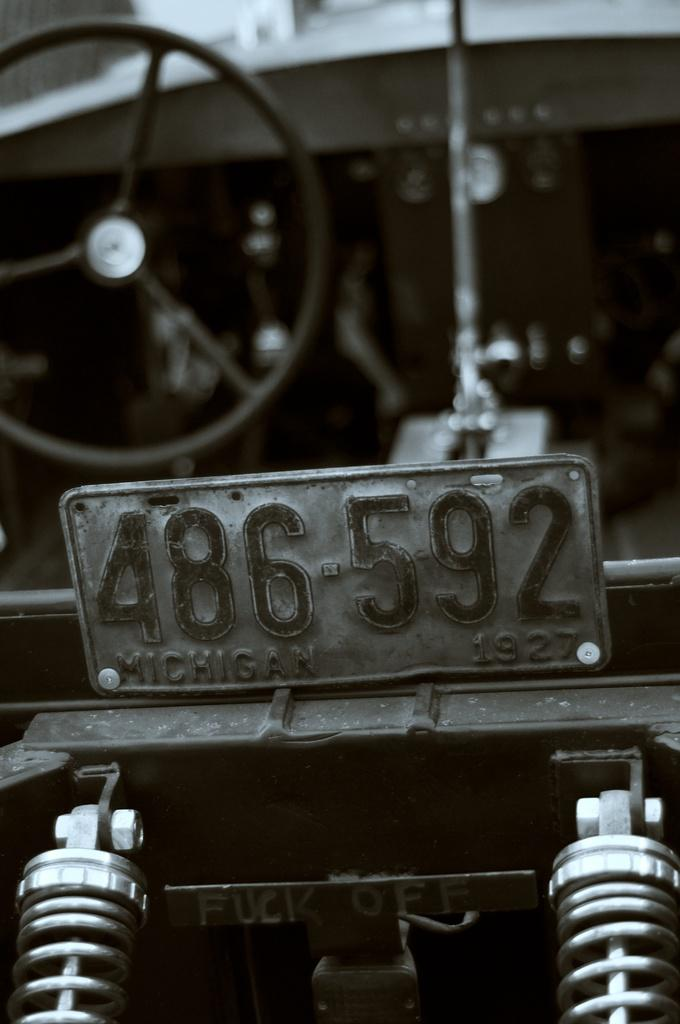What type of vehicle is in the image? The image contains a vehicle with a number plate. What specific components can be seen in the image? There are metal springs and a board with writing visible in the image. How is the vehicle configured? The vehicle has a steering wheel in the back. What type of cap is the vessel wearing in the image? There is no vessel or cap present in the image. Can you describe the bedroom in the image? There is no bedroom present in the image. 